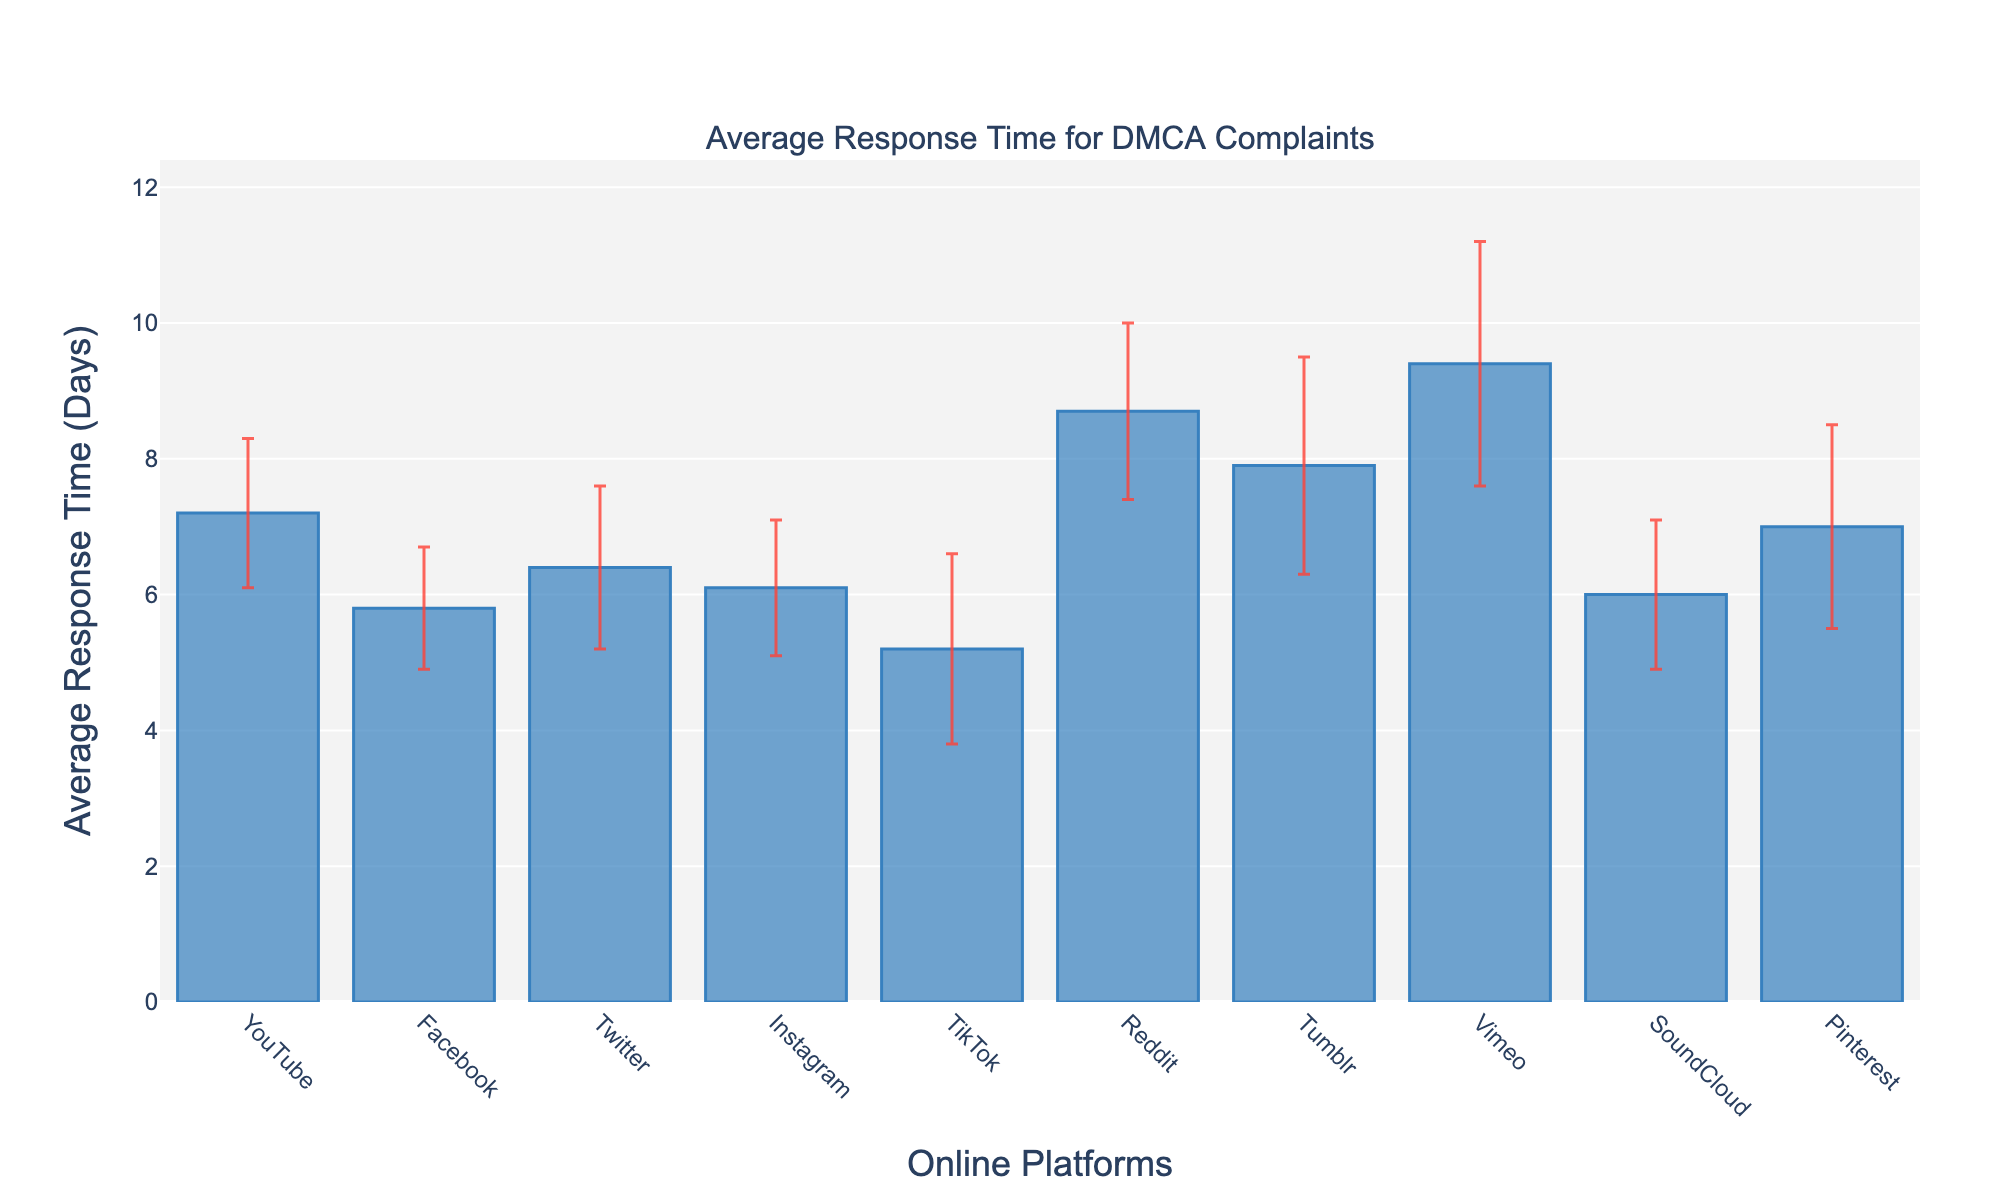What is the platform with the longest average response time for DMCA complaints? The platform with the highest bar on the chart represents the longest average response time. We can see that Vimeo has the highest bar.
Answer: Vimeo What is the shortest average response time across the platforms? By comparing the heights of the bars, TikTok has the shortest bar indicating the shortest average response time.
Answer: TikTok Which platform has an average response time of around 8.7 days? By looking at the labels on the x-axis and corresponding y-axis values, we can see that Reddit has an average response time of around 8.7 days.
Answer: Reddit What is the average response time for Instagram for DMCA complaints? To find Instagram's average response time, refer to the height of the bar for Instagram, which corresponds to 6.1 days.
Answer: 6.1 days Compare the average response times of Facebook and Twitter. Which platform is faster, and by how many days? Facebook has an average response time of 5.8 days while Twitter has 6.4 days. The difference is 6.4 - 5.8 = 0.6 days. Therefore, Facebook is faster by 0.6 days.
Answer: Facebook; 0.6 days Which platform has the highest variability in response times as indicated by the error bars? The platform with the largest error bars (thickest red lines) shows the highest variability. Vimeo’s error bar appears the largest.
Answer: Vimeo What is the average response time range (low to high) for Pinterest considering its error bars? Pinterest's average response time is 7.0 days with an error bar of ±1.5 days. So, the range is 7.0 - 1.5 to 7.0 + 1.5, which is 5.5 to 8.5 days.
Answer: 5.5 to 8.5 days How does SoundCloud’s average response time compare to YouTube’s, and what’s the difference? SoundCloud’s average response time is 6.0 days, while YouTube’s is 7.2 days. The difference is 7.2 - 6.0 = 1.2 days. YouTube is 1.2 days slower.
Answer: YouTube; 1.2 days Which platforms have an average response time greater than 7.0 days? By looking at bars taller than 7.0 on the y-axis, YouTube, Reddit, Tumblr, Vimeo, and Pinterest have average response times greater than 7.0 days.
Answer: YouTube, Reddit, Tumblr, Vimeo, Pinterest What’s the combined average response time for DMCA complaints for Facebook, Instagram, and Twitter? Adding up the average response times: Facebook (5.8) + Instagram (6.1) + Twitter (6.4) = 18.3 days
Answer: 18.3 days 